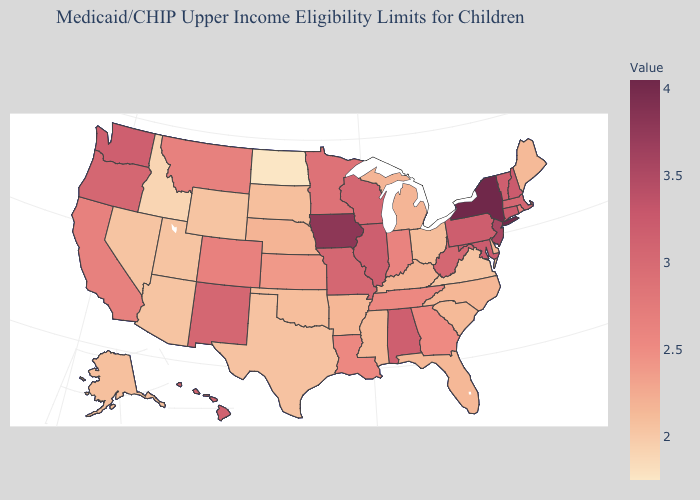Among the states that border New Hampshire , does Massachusetts have the highest value?
Be succinct. No. Does Kansas have a higher value than Wyoming?
Answer briefly. Yes. Among the states that border Vermont , does New Hampshire have the highest value?
Be succinct. No. Does Maine have the highest value in the Northeast?
Give a very brief answer. No. Which states hav the highest value in the MidWest?
Write a very short answer. Iowa. Among the states that border North Dakota , which have the highest value?
Keep it brief. Minnesota. 